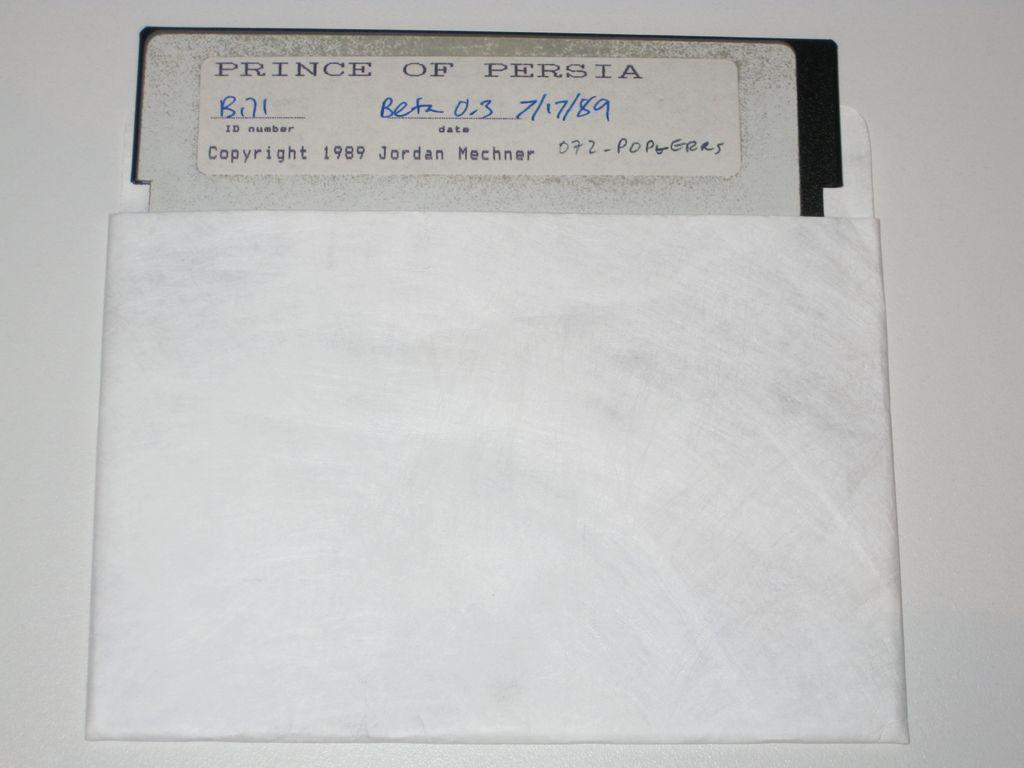<image>
Summarize the visual content of the image. An old sleeved floppy disc from 1989 for Prince of Persia software. 